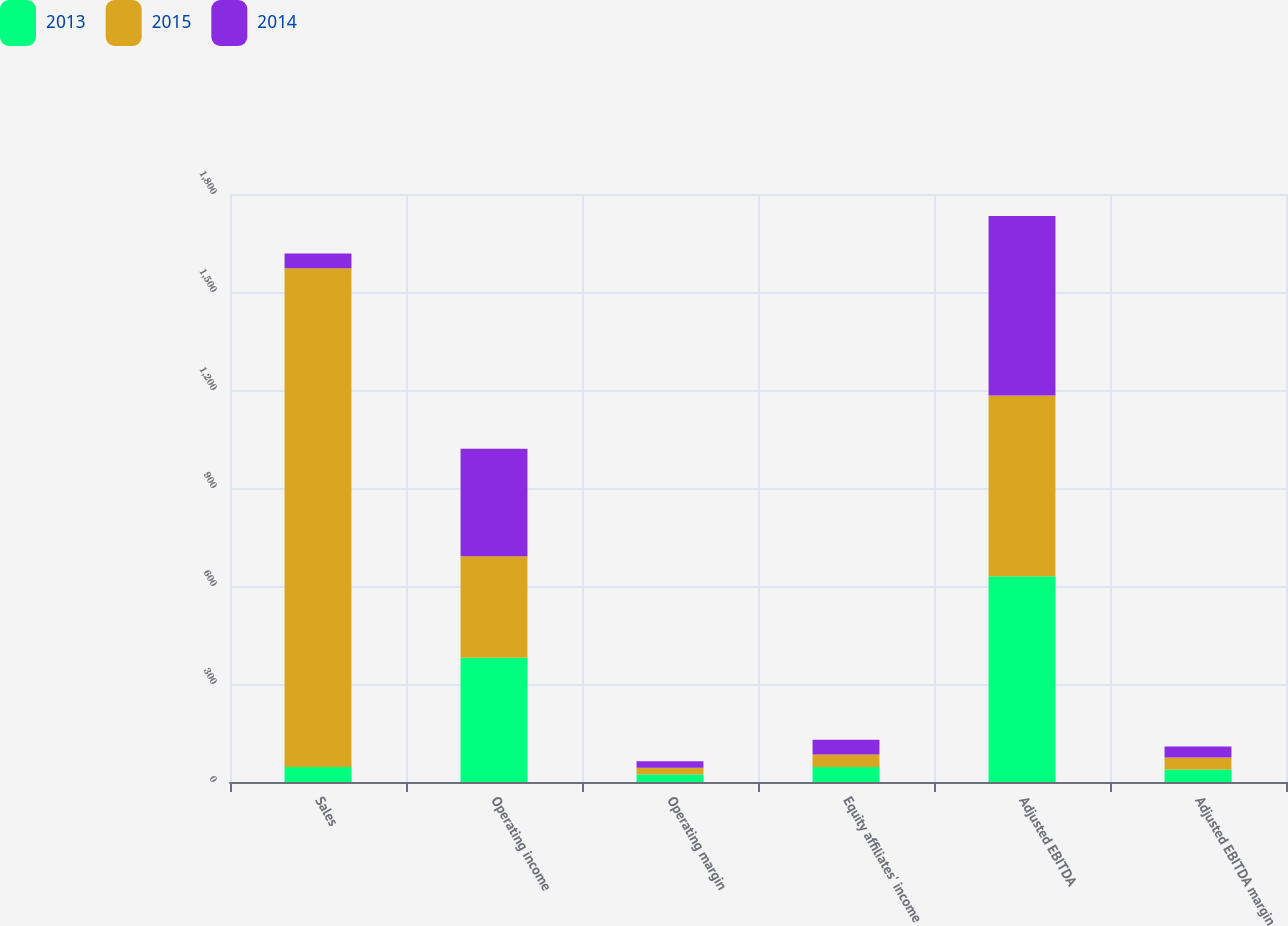<chart> <loc_0><loc_0><loc_500><loc_500><stacked_bar_chart><ecel><fcel>Sales<fcel>Operating income<fcel>Operating margin<fcel>Equity affiliates' income<fcel>Adjusted EBITDA<fcel>Adjusted EBITDA margin<nl><fcel>2013<fcel>45.55<fcel>380.5<fcel>23.2<fcel>46.1<fcel>629.5<fcel>38.4<nl><fcel>2015<fcel>1527<fcel>310.4<fcel>20.3<fcel>38<fcel>553.7<fcel>36.3<nl><fcel>2014<fcel>45.55<fcel>329.3<fcel>20.4<fcel>45<fcel>549.2<fcel>34<nl></chart> 